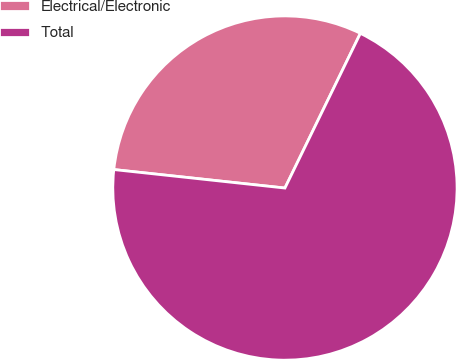Convert chart. <chart><loc_0><loc_0><loc_500><loc_500><pie_chart><fcel>Electrical/Electronic<fcel>Total<nl><fcel>30.51%<fcel>69.49%<nl></chart> 